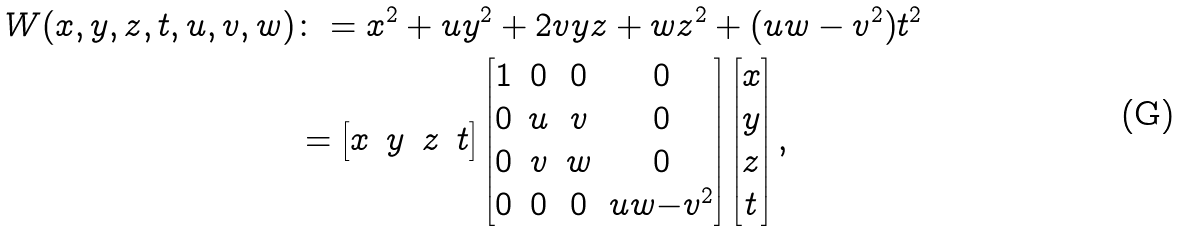<formula> <loc_0><loc_0><loc_500><loc_500>W ( x , y , z , t , u , v , w ) & \colon = x ^ { 2 } + u y ^ { 2 } + 2 v y z + w z ^ { 2 } + ( u w - v ^ { 2 } ) t ^ { 2 } \\ & = \begin{bmatrix} x & y & z & t \\ \end{bmatrix} \begin{bmatrix} 1 & 0 & 0 & 0 \\ 0 & u & v & 0 \\ 0 & v & w & 0 \\ 0 & 0 & 0 & u w { - } v ^ { 2 } \\ \end{bmatrix} \begin{bmatrix} x \\ y \\ z \\ t \\ \end{bmatrix} ,</formula> 